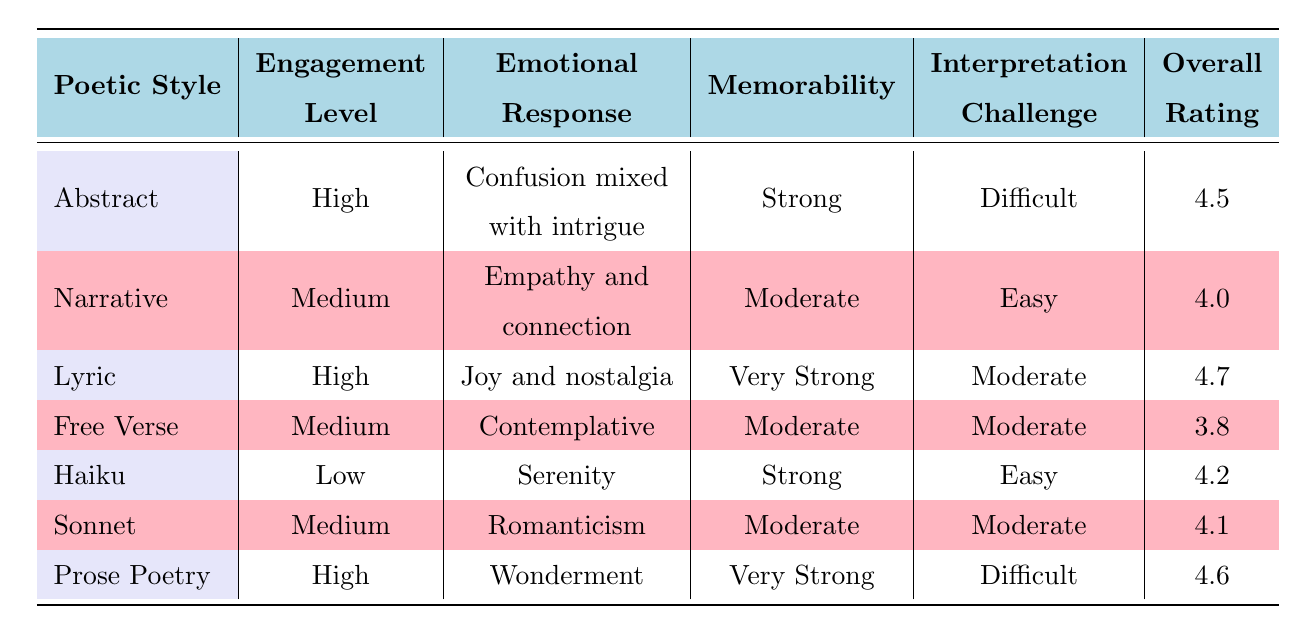What is the engagement level of the Lyric style? The engagement level of Lyric style is listed directly in the table under the "Engagement Level" column. It states "High" for the Lyric poetic style.
Answer: High Which poetic style has the strongest memorability? By comparing the memorability values across all poetic styles, "Lyric" has the highest rating of "Very Strong," thus it is the one with the strongest memorability.
Answer: Lyric Is the emotional response to Free Verse style contemplative? The emotional response for Free Verse style is explicitly stated in the table, which shows "Contemplative" under the "Emotional Response" column. Therefore, the statement is true.
Answer: Yes What is the overall rating of Abstract poetry? The overall rating for Abstract poetry is found directly in the table under the "Overall Rating" column, where it shows a value of 4.5.
Answer: 4.5 Which poetic style has a higher overall rating, Haiku or Sonnet? The overall ratings for Haiku and Sonnet are 4.2 and 4.1 respectively, allowing us to compare them. Since 4.2 is greater than 4.1, the conclusion is that Haiku has a higher overall rating.
Answer: Haiku What is the average overall rating of all poetic styles? To find the average overall rating, we sum the ratings: (4.5 + 4.0 + 4.7 + 3.8 + 4.2 + 4.1 + 4.6) = 29.9. Since there are 7 styles, the average is 29.9 / 7 = approximately 4.27.
Answer: 4.27 Are both Prose Poetry and Lyric styles marked as having a high engagement level? Prose Poetry and Lyric have their engagement levels listed in the table. Prose Poetry is marked "High" and Lyric is also marked "High," confirming that both styles have a high engagement level.
Answer: Yes Which poetic style has the easiest interpretation challenge? The interpretation challenge levels are listed per poetic style; "Haiku" is marked as "Easy," while others register as "Difficult," "Moderate," or "Easy." Since it has the indication of "Easy," Haiku is the answer.
Answer: Haiku What emotional response characterizes the Narrative style? The table specifically provides the emotional response for Narrative style as "Empathy and connection," making it a straightforward retrieval of that information.
Answer: Empathy and connection 